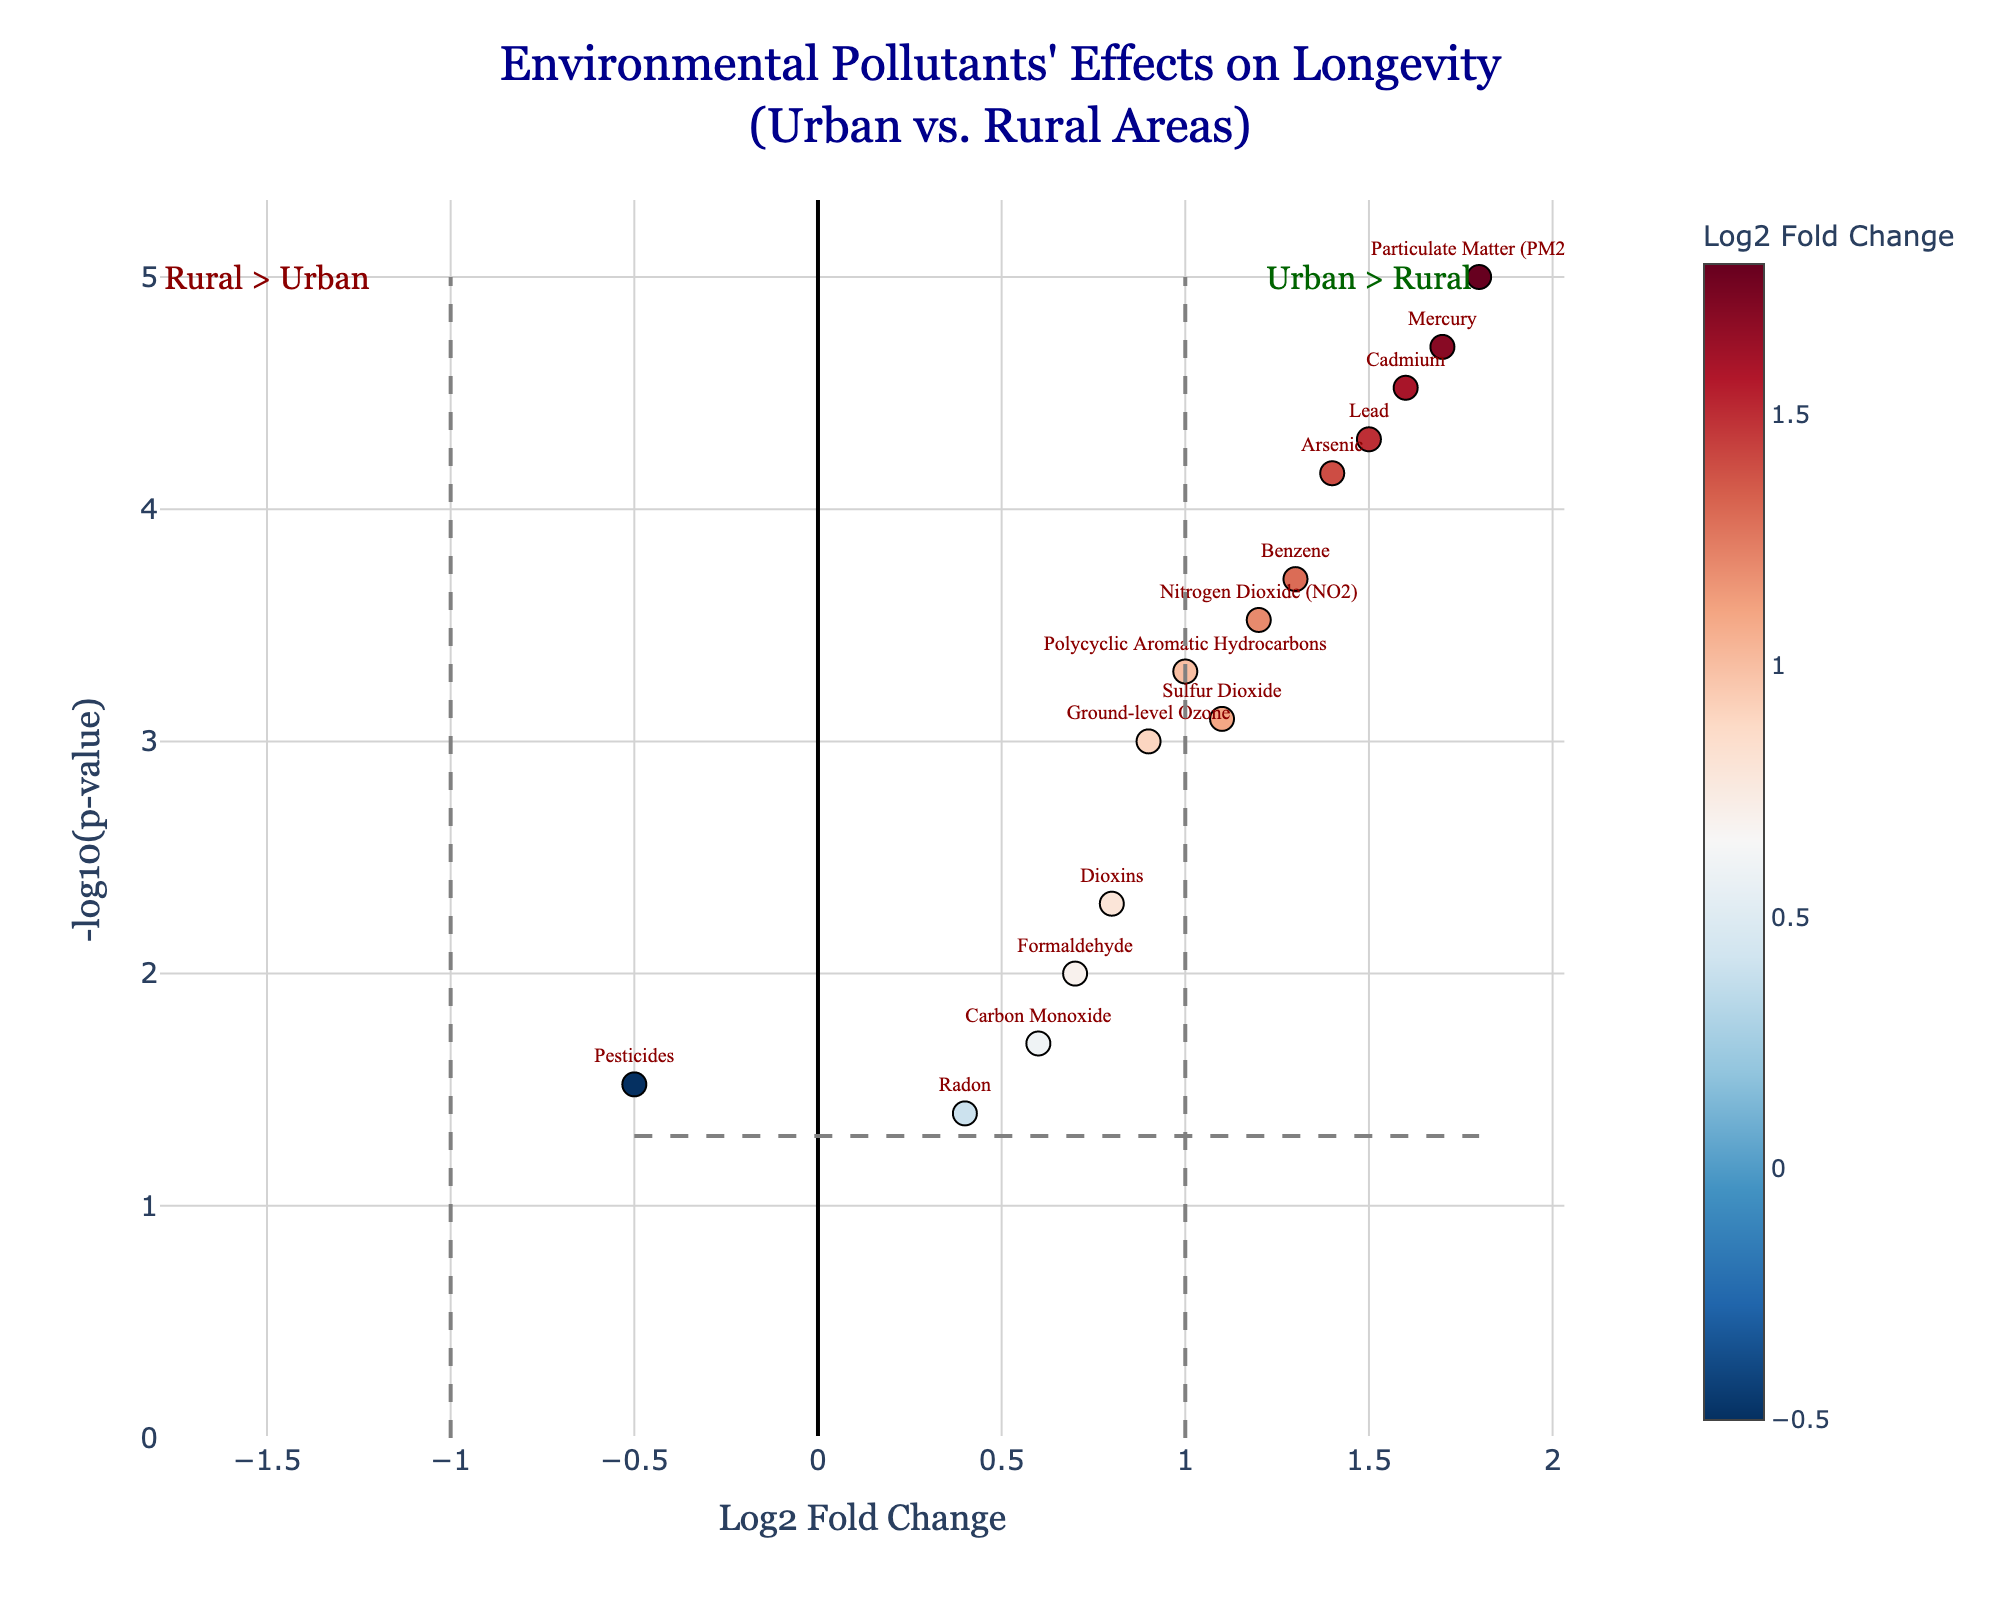Which pollutant has the highest Log2 Fold Change? Look at the x-axis for the pollutant with the highest positive value.
Answer: Particulate Matter (PM2.5) Which pollutants have a negative Log2 Fold Change? Identify pollutants with an x-axis value below zero.
Answer: Pesticides, Radon What is the p-value threshold line on the y-axis? Locate the horizontal line and read the corresponding y-axis value.
Answer: 1.30 How many pollutants have a Log2 Fold Change over 1? Count the data points with x values greater than 1.
Answer: 8 Which pollutant shows the smallest effect in Log2 Fold Change? Identify the pollutant closest to the y-axis.
Answer: Radon What does the color gradient represent in the plot? Refer to the colorbar's title to understand the representation.
Answer: Log2 Fold Change How many pollutants have significant p-values below 0.05? Count data points above the p-value threshold line.
Answer: 12 Which pollutants are more significant: those from urban or rural areas? Check the annotations for "Urban > Rural" and "Rural > Urban" and observe the number of data points on each side.
Answer: Urban > Rural What's the relationship between Log2 Fold Change and -log10(p-value)? Higher -log10(p-value) often corresponds to higher Log2 Fold Change.
Answer: Positive relationship Which pollutant is located at the top right of the plot, indicating high significance and high urban impact? Find the pollutant in the top-right corner of the plot.
Answer: Particulate Matter (PM2.5) 